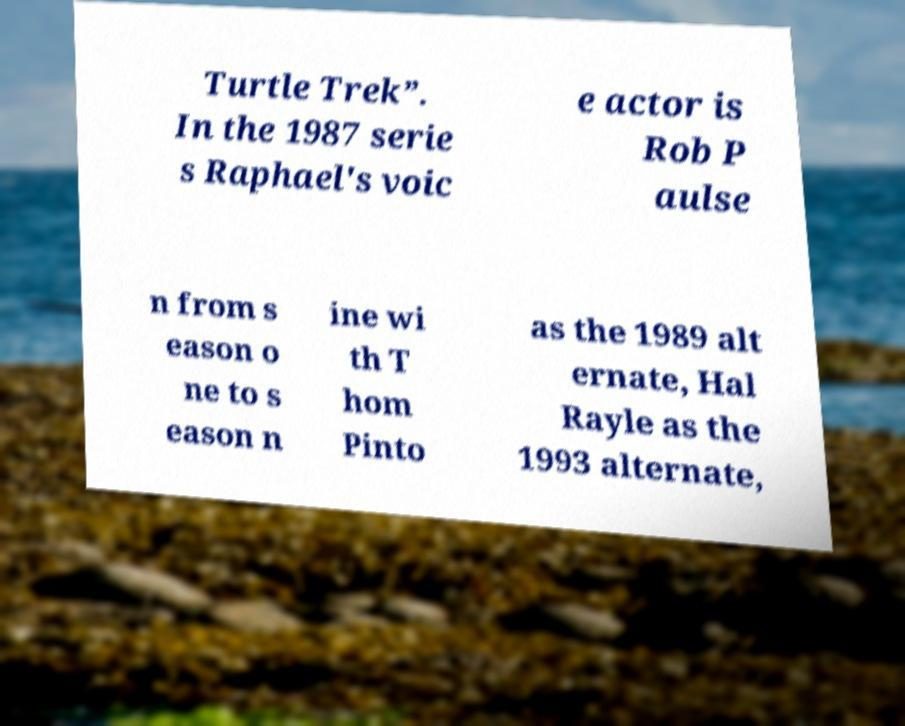Could you assist in decoding the text presented in this image and type it out clearly? Turtle Trek”. In the 1987 serie s Raphael's voic e actor is Rob P aulse n from s eason o ne to s eason n ine wi th T hom Pinto as the 1989 alt ernate, Hal Rayle as the 1993 alternate, 